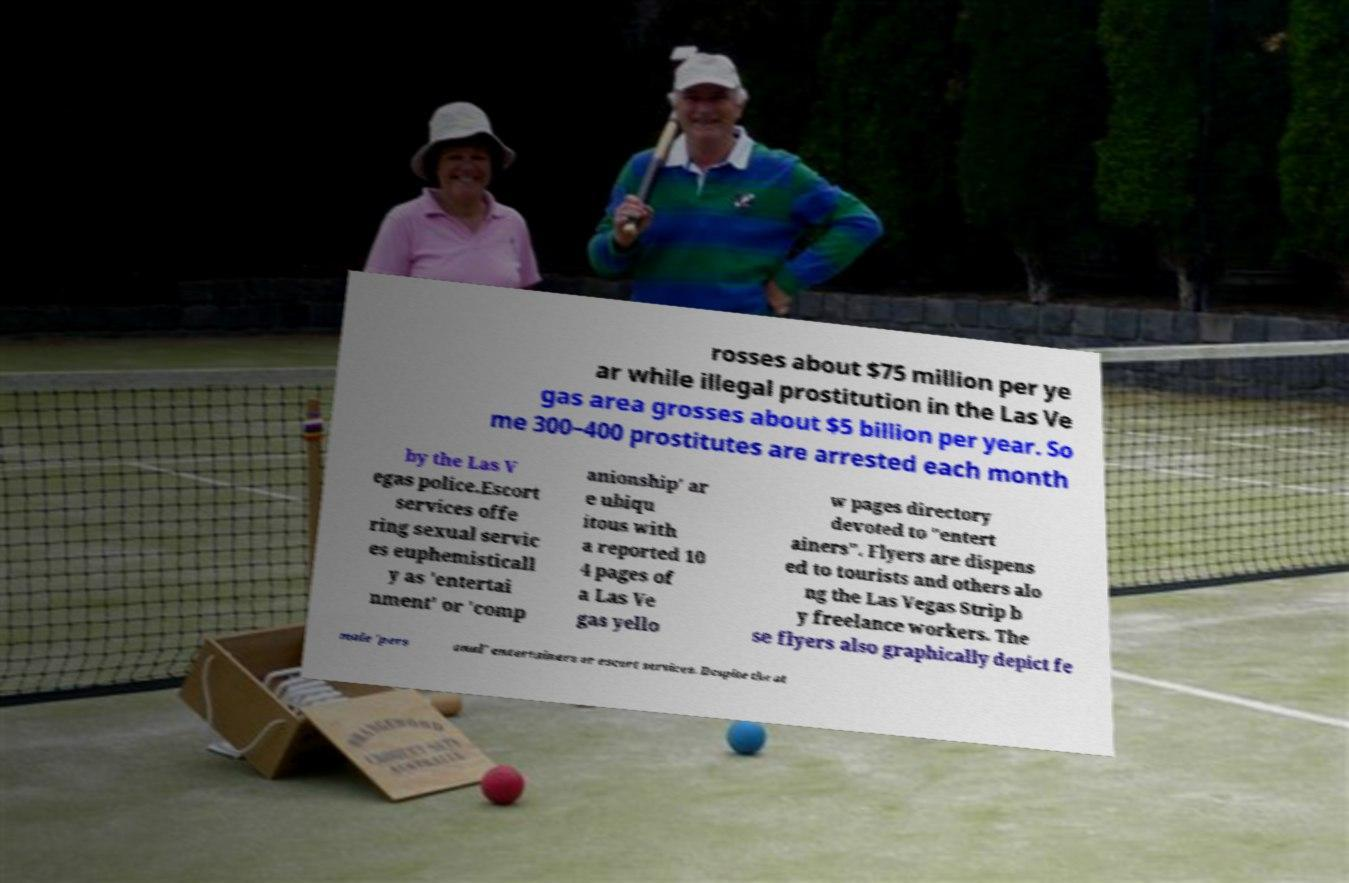I need the written content from this picture converted into text. Can you do that? rosses about $75 million per ye ar while illegal prostitution in the Las Ve gas area grosses about $5 billion per year. So me 300–400 prostitutes are arrested each month by the Las V egas police.Escort services offe ring sexual servic es euphemisticall y as 'entertai nment' or 'comp anionship' ar e ubiqu itous with a reported 10 4 pages of a Las Ve gas yello w pages directory devoted to "entert ainers". Flyers are dispens ed to tourists and others alo ng the Las Vegas Strip b y freelance workers. The se flyers also graphically depict fe male 'pers onal' entertainers or escort services. Despite the at 